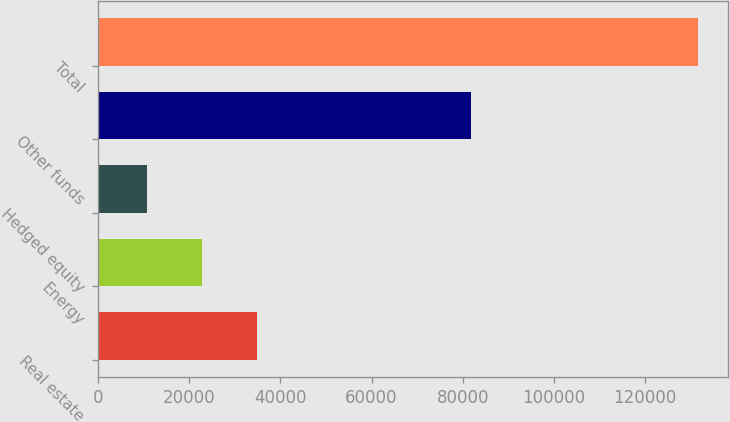Convert chart. <chart><loc_0><loc_0><loc_500><loc_500><bar_chart><fcel>Real estate<fcel>Energy<fcel>Hedged equity<fcel>Other funds<fcel>Total<nl><fcel>34937.8<fcel>22848.9<fcel>10760<fcel>81859<fcel>131649<nl></chart> 